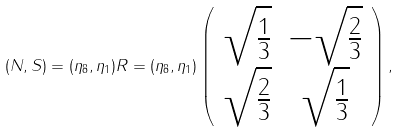<formula> <loc_0><loc_0><loc_500><loc_500>( N , S ) = ( \eta _ { 8 } , \eta _ { 1 } ) R = ( \eta _ { 8 } , \eta _ { 1 } ) \left ( \begin{array} { c c } \sqrt { \frac { 1 } { 3 } } & - \sqrt { \frac { 2 } { 3 } } \\ \sqrt { \frac { 2 } { 3 } } & \sqrt { \frac { 1 } { 3 } } \end{array} \right ) ,</formula> 